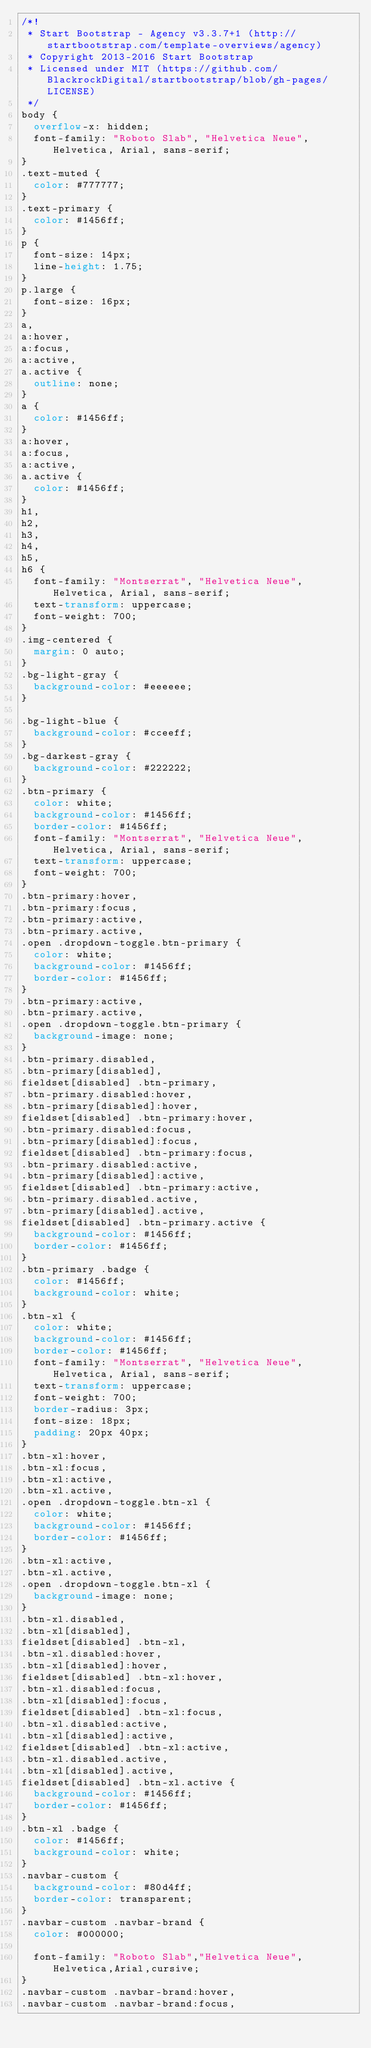Convert code to text. <code><loc_0><loc_0><loc_500><loc_500><_CSS_>/*!
 * Start Bootstrap - Agency v3.3.7+1 (http://startbootstrap.com/template-overviews/agency)
 * Copyright 2013-2016 Start Bootstrap
 * Licensed under MIT (https://github.com/BlackrockDigital/startbootstrap/blob/gh-pages/LICENSE)
 */
body {
  overflow-x: hidden;
  font-family: "Roboto Slab", "Helvetica Neue", Helvetica, Arial, sans-serif;
}
.text-muted {
  color: #777777;
}
.text-primary {
  color: #1456ff;
}
p {
  font-size: 14px;
  line-height: 1.75;
}
p.large {
  font-size: 16px;
}
a,
a:hover,
a:focus,
a:active,
a.active {
  outline: none;
}
a {
  color: #1456ff;
}
a:hover,
a:focus,
a:active,
a.active {
  color: #1456ff;
}
h1,
h2,
h3,
h4,
h5,
h6 {
  font-family: "Montserrat", "Helvetica Neue", Helvetica, Arial, sans-serif;
  text-transform: uppercase;
  font-weight: 700;
}
.img-centered {
  margin: 0 auto;
}
.bg-light-gray {
  background-color: #eeeeee;
}

.bg-light-blue {
  background-color: #cceeff;
}
.bg-darkest-gray {
  background-color: #222222;
}
.btn-primary {
  color: white;
  background-color: #1456ff;
  border-color: #1456ff;
  font-family: "Montserrat", "Helvetica Neue", Helvetica, Arial, sans-serif;
  text-transform: uppercase;
  font-weight: 700;
}
.btn-primary:hover,
.btn-primary:focus,
.btn-primary:active,
.btn-primary.active,
.open .dropdown-toggle.btn-primary {
  color: white;
  background-color: #1456ff;
  border-color: #1456ff;
}
.btn-primary:active,
.btn-primary.active,
.open .dropdown-toggle.btn-primary {
  background-image: none;
}
.btn-primary.disabled,
.btn-primary[disabled],
fieldset[disabled] .btn-primary,
.btn-primary.disabled:hover,
.btn-primary[disabled]:hover,
fieldset[disabled] .btn-primary:hover,
.btn-primary.disabled:focus,
.btn-primary[disabled]:focus,
fieldset[disabled] .btn-primary:focus,
.btn-primary.disabled:active,
.btn-primary[disabled]:active,
fieldset[disabled] .btn-primary:active,
.btn-primary.disabled.active,
.btn-primary[disabled].active,
fieldset[disabled] .btn-primary.active {
  background-color: #1456ff;
  border-color: #1456ff;
}
.btn-primary .badge {
  color: #1456ff;
  background-color: white;
}
.btn-xl {
  color: white;
  background-color: #1456ff;
  border-color: #1456ff;
  font-family: "Montserrat", "Helvetica Neue", Helvetica, Arial, sans-serif;
  text-transform: uppercase;
  font-weight: 700;
  border-radius: 3px;
  font-size: 18px;
  padding: 20px 40px;
}
.btn-xl:hover,
.btn-xl:focus,
.btn-xl:active,
.btn-xl.active,
.open .dropdown-toggle.btn-xl {
  color: white;
  background-color: #1456ff;
  border-color: #1456ff;
}
.btn-xl:active,
.btn-xl.active,
.open .dropdown-toggle.btn-xl {
  background-image: none;
}
.btn-xl.disabled,
.btn-xl[disabled],
fieldset[disabled] .btn-xl,
.btn-xl.disabled:hover,
.btn-xl[disabled]:hover,
fieldset[disabled] .btn-xl:hover,
.btn-xl.disabled:focus,
.btn-xl[disabled]:focus,
fieldset[disabled] .btn-xl:focus,
.btn-xl.disabled:active,
.btn-xl[disabled]:active,
fieldset[disabled] .btn-xl:active,
.btn-xl.disabled.active,
.btn-xl[disabled].active,
fieldset[disabled] .btn-xl.active {
  background-color: #1456ff;
  border-color: #1456ff;
}
.btn-xl .badge {
  color: #1456ff;
  background-color: white;
}
.navbar-custom {
  background-color: #80d4ff;
  border-color: transparent;
}
.navbar-custom .navbar-brand {
  color: #000000;

  font-family: "Roboto Slab","Helvetica Neue",Helvetica,Arial,cursive;
}
.navbar-custom .navbar-brand:hover,
.navbar-custom .navbar-brand:focus,</code> 